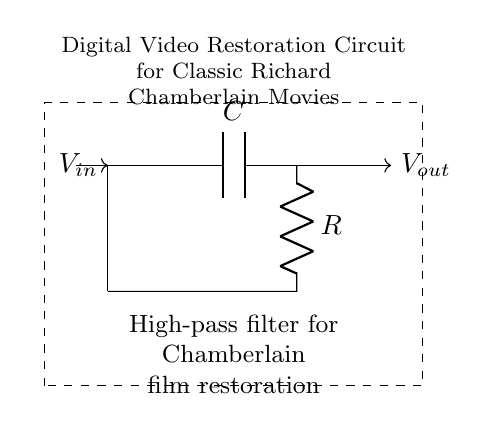What type of filter is this circuit? The circuit is labeled as a high-pass filter. This is indicated by its name in the node description, explicitly stating its functionality.
Answer: high-pass filter What components are present in the circuit? The circuit contains a capacitor (C) and a resistor (R). These components are labeled in the circuit diagram, clearly indicating their presence.
Answer: capacitor and resistor What is the direction of the input voltage? The input voltage direction is towards the left node and is marked with an arrow indicating the flow of voltage into the circuit.
Answer: left What is the output voltage referenced to? The output voltage is referenced to the right side of the circuit, where it exits and is shown with an arrow pointing outward.
Answer: the right side How does the output relate to the input in a high-pass filter? In a high-pass filter, the output allows high-frequency signals to pass through while attenuating low-frequency signals. This characteristic defines its function in filtering.
Answer: allows high frequencies What is the purpose of this circuit? The circuit is designed for digital video restoration, specifically of classic Richard Chamberlain movies, as stated in the additional node description.
Answer: digital video restoration What effect does increasing the capacitance have on the filter? Increasing the capacitance leads to a lower cutoff frequency, allowing more low-frequency signals to pass through. This reasoning involves understanding the capacitive reactance and its effect on frequency response.
Answer: lowers cutoff frequency 